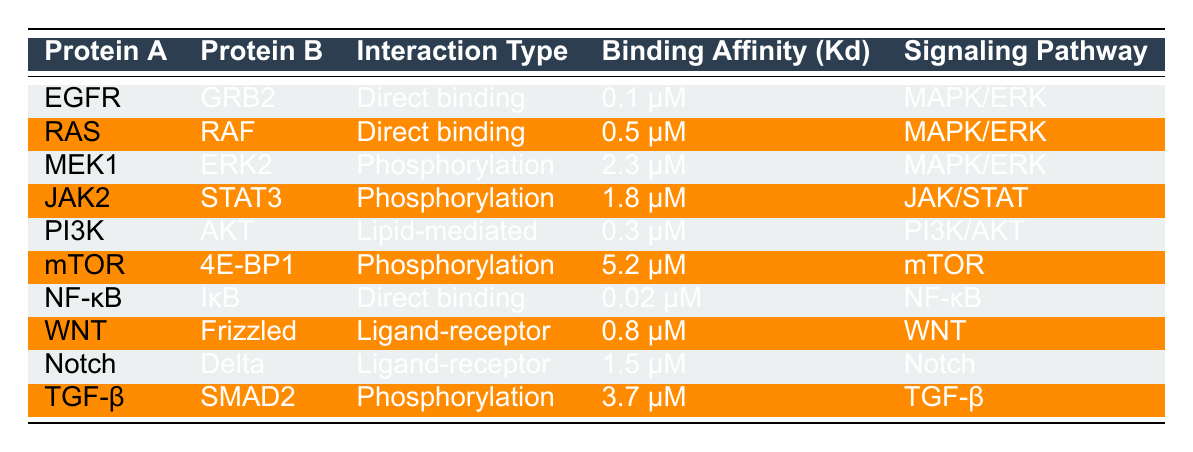What is the binding affinity of EGFR interacting with GRB2? The binding affinity listed for the interaction between EGFR and GRB2 is 0.1 μM. This information can be directly retrieved from the corresponding row in the table.
Answer: 0.1 μM Which interaction type is associated with the highest binding affinity? By reviewing the binding affinities in the table, the interaction with the highest binding affinity is phosphorylation between mTOR and 4E-BP1, with a binding affinity of 5.2 μM, as seen in the relevant row.
Answer: Phosphorylation Is NF-κB directly binding to IκB? The table indicates that NF-κB and IκB interact through direct binding, as outlined in the row describing their relationship. Therefore, the answer is yes.
Answer: Yes What is the average binding affinity of all the phosphorylation interactions? To find the average binding affinity for phosphorylation, we first identify the relevant entries: MEK1 with ERK2 (2.3 μM), JAK2 with STAT3 (1.8 μM), mTOR with 4E-BP1 (5.2 μM), and TGF-β with SMAD2 (3.7 μM). The total is 2.3 + 1.8 + 5.2 + 3.7 = 13.0 μM. Given there are 4 interactions, the average is 13.0/4 = 3.25 μM.
Answer: 3.25 μM How many unique signaling pathways are represented in the table? By scanning through the signaling pathways listed in the table, we see five unique pathways: MAPK/ERK, JAK/STAT, PI3K/AKT, mTOR, and WNT. This can be confirmed by checking the unique entries under the signaling pathway column.
Answer: 5 